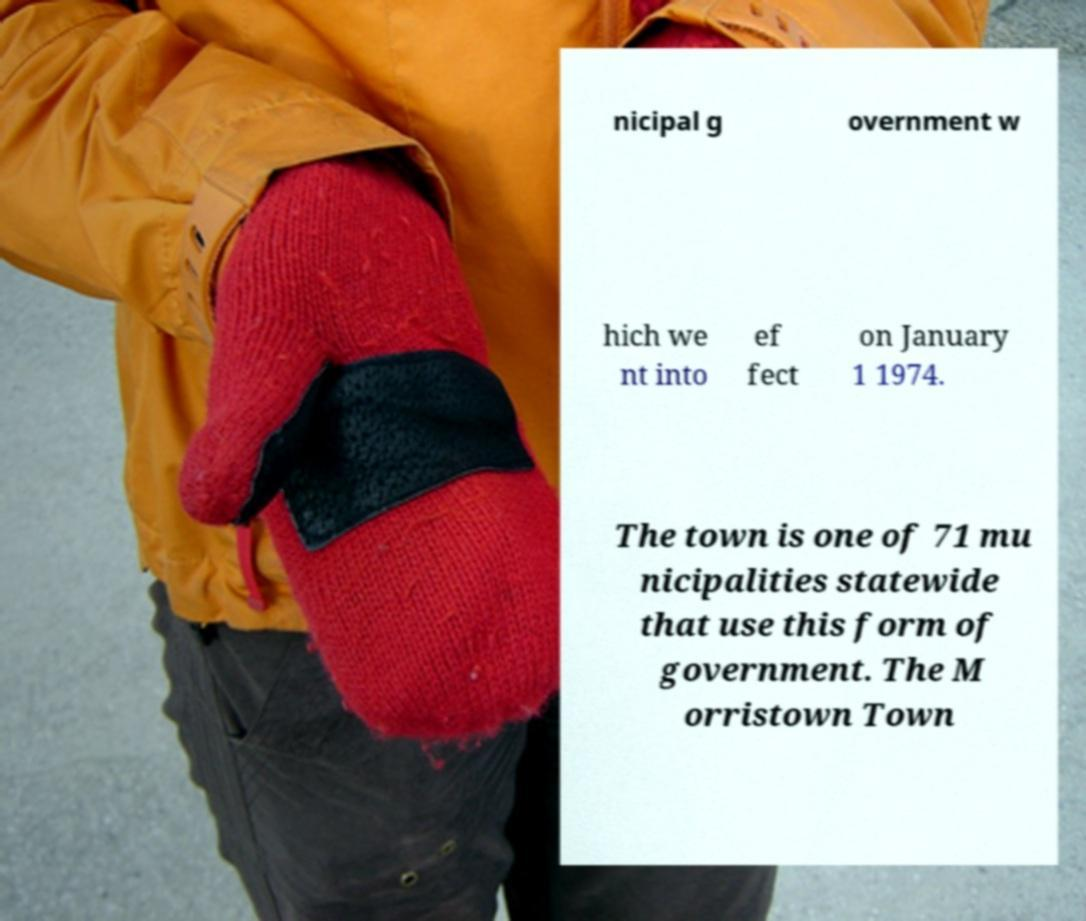Please identify and transcribe the text found in this image. nicipal g overnment w hich we nt into ef fect on January 1 1974. The town is one of 71 mu nicipalities statewide that use this form of government. The M orristown Town 